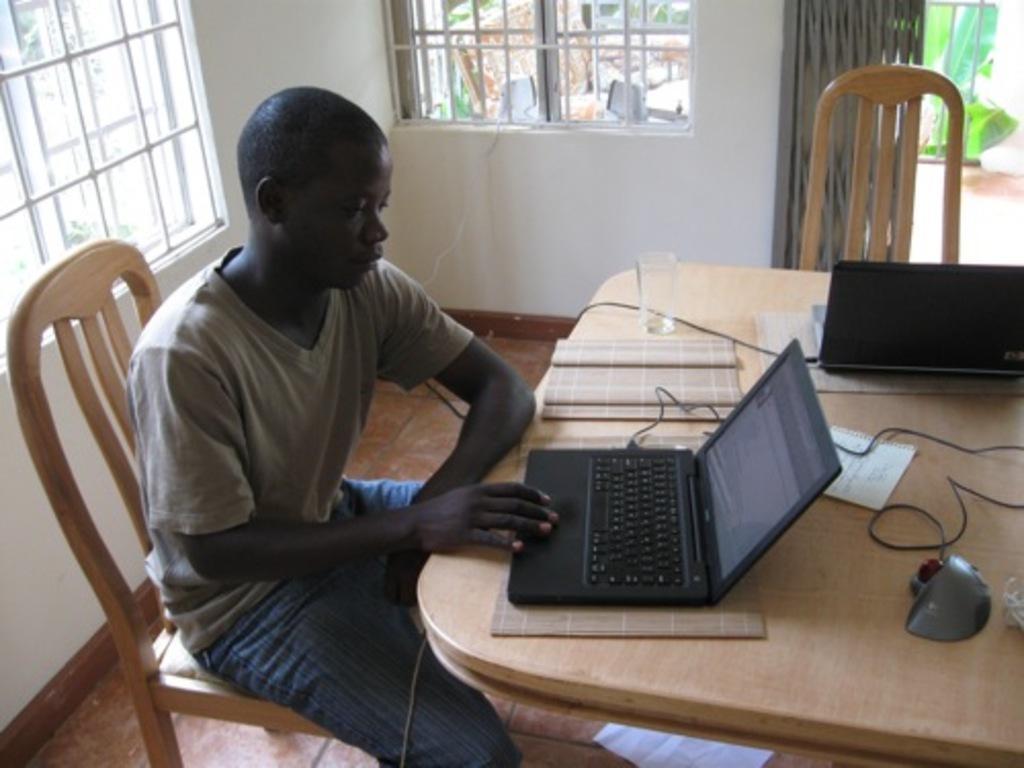In one or two sentences, can you explain what this image depicts? In the given image we can see a person sitting on chair, in front of him there is a laptop. The person is working on it. There is a glass on a table. This is a window 